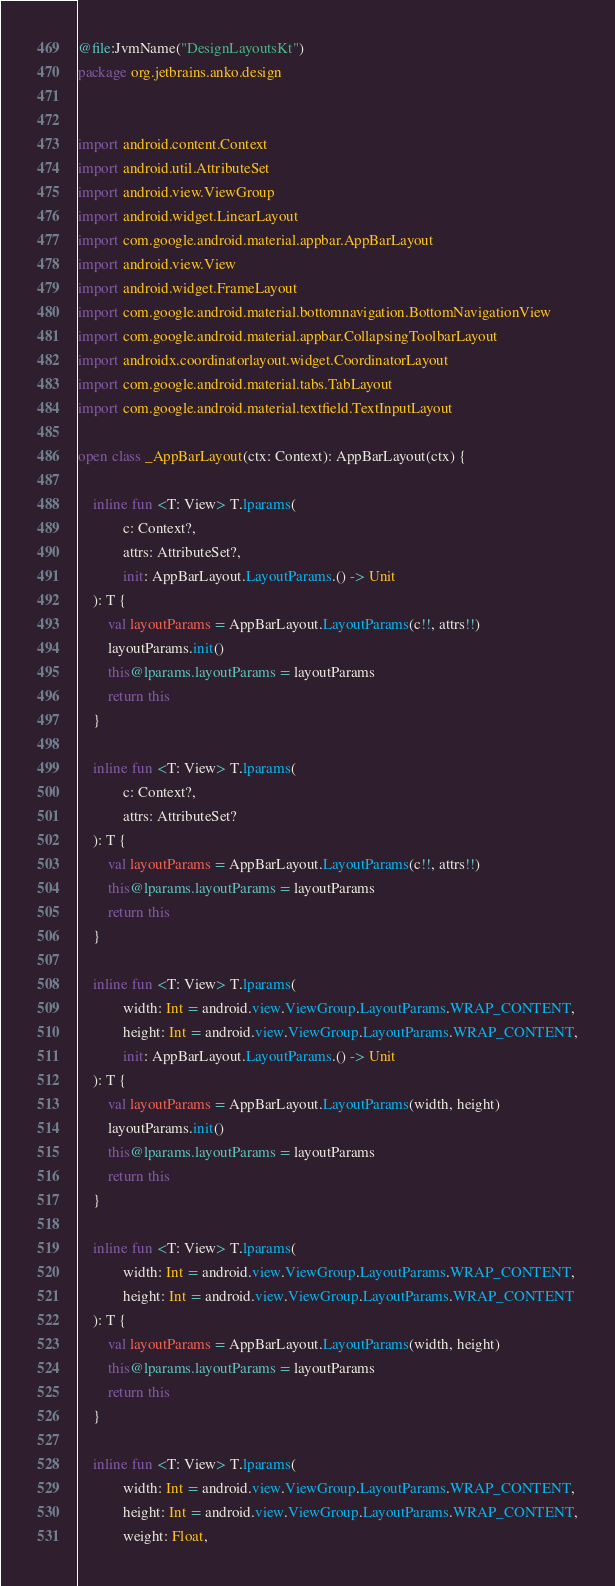Convert code to text. <code><loc_0><loc_0><loc_500><loc_500><_Kotlin_>@file:JvmName("DesignLayoutsKt")
package org.jetbrains.anko.design


import android.content.Context
import android.util.AttributeSet
import android.view.ViewGroup
import android.widget.LinearLayout
import com.google.android.material.appbar.AppBarLayout
import android.view.View
import android.widget.FrameLayout
import com.google.android.material.bottomnavigation.BottomNavigationView
import com.google.android.material.appbar.CollapsingToolbarLayout
import androidx.coordinatorlayout.widget.CoordinatorLayout
import com.google.android.material.tabs.TabLayout
import com.google.android.material.textfield.TextInputLayout

open class _AppBarLayout(ctx: Context): AppBarLayout(ctx) {

    inline fun <T: View> T.lparams(
            c: Context?,
            attrs: AttributeSet?,
            init: AppBarLayout.LayoutParams.() -> Unit
    ): T {
        val layoutParams = AppBarLayout.LayoutParams(c!!, attrs!!)
        layoutParams.init()
        this@lparams.layoutParams = layoutParams
        return this
    }

    inline fun <T: View> T.lparams(
            c: Context?,
            attrs: AttributeSet?
    ): T {
        val layoutParams = AppBarLayout.LayoutParams(c!!, attrs!!)
        this@lparams.layoutParams = layoutParams
        return this
    }

    inline fun <T: View> T.lparams(
            width: Int = android.view.ViewGroup.LayoutParams.WRAP_CONTENT,
            height: Int = android.view.ViewGroup.LayoutParams.WRAP_CONTENT,
            init: AppBarLayout.LayoutParams.() -> Unit
    ): T {
        val layoutParams = AppBarLayout.LayoutParams(width, height)
        layoutParams.init()
        this@lparams.layoutParams = layoutParams
        return this
    }

    inline fun <T: View> T.lparams(
            width: Int = android.view.ViewGroup.LayoutParams.WRAP_CONTENT,
            height: Int = android.view.ViewGroup.LayoutParams.WRAP_CONTENT
    ): T {
        val layoutParams = AppBarLayout.LayoutParams(width, height)
        this@lparams.layoutParams = layoutParams
        return this
    }

    inline fun <T: View> T.lparams(
            width: Int = android.view.ViewGroup.LayoutParams.WRAP_CONTENT,
            height: Int = android.view.ViewGroup.LayoutParams.WRAP_CONTENT,
            weight: Float,</code> 